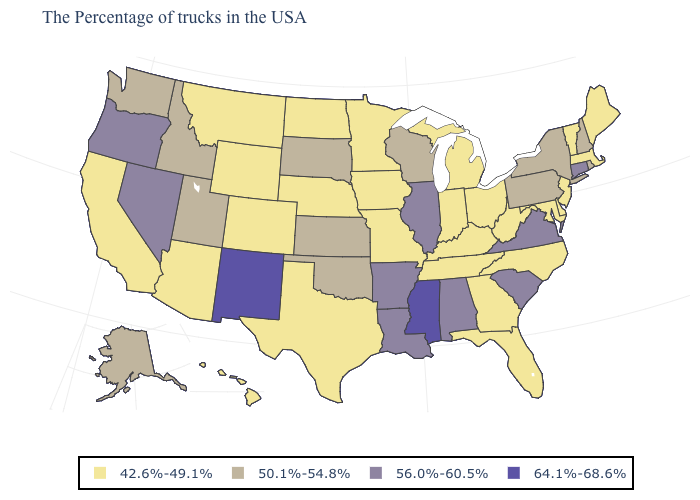What is the lowest value in the South?
Concise answer only. 42.6%-49.1%. What is the value of Nebraska?
Quick response, please. 42.6%-49.1%. Does the map have missing data?
Give a very brief answer. No. Which states have the lowest value in the West?
Answer briefly. Wyoming, Colorado, Montana, Arizona, California, Hawaii. Does Alabama have the lowest value in the USA?
Write a very short answer. No. What is the value of Kansas?
Short answer required. 50.1%-54.8%. Does Nebraska have a lower value than Georgia?
Short answer required. No. Among the states that border Missouri , which have the lowest value?
Be succinct. Kentucky, Tennessee, Iowa, Nebraska. Among the states that border North Carolina , which have the highest value?
Write a very short answer. Virginia, South Carolina. Name the states that have a value in the range 50.1%-54.8%?
Be succinct. Rhode Island, New Hampshire, New York, Pennsylvania, Wisconsin, Kansas, Oklahoma, South Dakota, Utah, Idaho, Washington, Alaska. What is the highest value in states that border New York?
Short answer required. 56.0%-60.5%. Does Texas have a higher value than South Carolina?
Be succinct. No. What is the highest value in states that border Maryland?
Give a very brief answer. 56.0%-60.5%. Name the states that have a value in the range 56.0%-60.5%?
Give a very brief answer. Connecticut, Virginia, South Carolina, Alabama, Illinois, Louisiana, Arkansas, Nevada, Oregon. What is the value of Nevada?
Keep it brief. 56.0%-60.5%. 